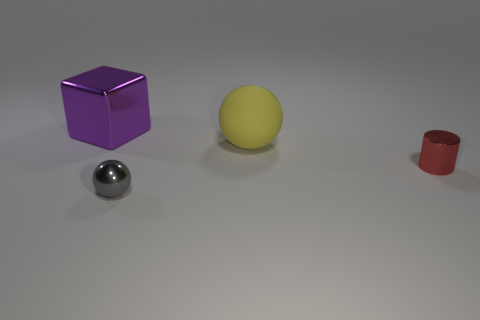Add 2 purple shiny blocks. How many objects exist? 6 Subtract all gray balls. How many balls are left? 1 Subtract all blocks. How many objects are left? 3 Subtract all brown blocks. How many green spheres are left? 0 Subtract all big purple objects. Subtract all purple balls. How many objects are left? 3 Add 4 large metal blocks. How many large metal blocks are left? 5 Add 1 tiny shiny spheres. How many tiny shiny spheres exist? 2 Subtract 1 purple blocks. How many objects are left? 3 Subtract 1 spheres. How many spheres are left? 1 Subtract all green balls. Subtract all yellow blocks. How many balls are left? 2 